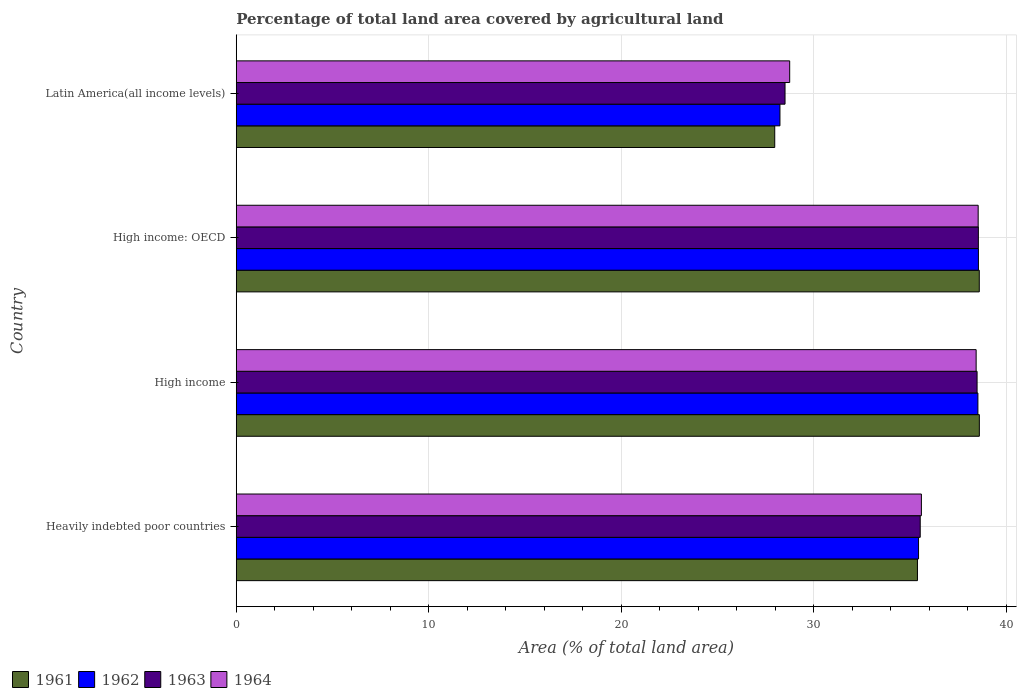How many different coloured bars are there?
Give a very brief answer. 4. Are the number of bars per tick equal to the number of legend labels?
Your answer should be very brief. Yes. Are the number of bars on each tick of the Y-axis equal?
Your answer should be compact. Yes. How many bars are there on the 2nd tick from the top?
Offer a terse response. 4. What is the label of the 2nd group of bars from the top?
Provide a succinct answer. High income: OECD. In how many cases, is the number of bars for a given country not equal to the number of legend labels?
Offer a terse response. 0. What is the percentage of agricultural land in 1962 in High income?
Keep it short and to the point. 38.52. Across all countries, what is the maximum percentage of agricultural land in 1964?
Offer a terse response. 38.53. Across all countries, what is the minimum percentage of agricultural land in 1964?
Your answer should be compact. 28.74. In which country was the percentage of agricultural land in 1961 minimum?
Make the answer very short. Latin America(all income levels). What is the total percentage of agricultural land in 1963 in the graph?
Keep it short and to the point. 141.05. What is the difference between the percentage of agricultural land in 1964 in Heavily indebted poor countries and that in Latin America(all income levels)?
Your answer should be very brief. 6.84. What is the difference between the percentage of agricultural land in 1963 in Heavily indebted poor countries and the percentage of agricultural land in 1961 in Latin America(all income levels)?
Make the answer very short. 7.56. What is the average percentage of agricultural land in 1961 per country?
Your answer should be compact. 35.13. What is the difference between the percentage of agricultural land in 1961 and percentage of agricultural land in 1964 in High income?
Your answer should be compact. 0.17. In how many countries, is the percentage of agricultural land in 1964 greater than 32 %?
Provide a short and direct response. 3. What is the ratio of the percentage of agricultural land in 1963 in High income: OECD to that in Latin America(all income levels)?
Your answer should be compact. 1.35. Is the difference between the percentage of agricultural land in 1961 in High income and Latin America(all income levels) greater than the difference between the percentage of agricultural land in 1964 in High income and Latin America(all income levels)?
Make the answer very short. Yes. What is the difference between the highest and the second highest percentage of agricultural land in 1963?
Ensure brevity in your answer.  0.07. What is the difference between the highest and the lowest percentage of agricultural land in 1962?
Ensure brevity in your answer.  10.31. Is it the case that in every country, the sum of the percentage of agricultural land in 1961 and percentage of agricultural land in 1964 is greater than the sum of percentage of agricultural land in 1963 and percentage of agricultural land in 1962?
Give a very brief answer. No. What does the 1st bar from the top in Heavily indebted poor countries represents?
Make the answer very short. 1964. Are the values on the major ticks of X-axis written in scientific E-notation?
Give a very brief answer. No. Does the graph contain grids?
Make the answer very short. Yes. How are the legend labels stacked?
Your answer should be compact. Horizontal. What is the title of the graph?
Your answer should be compact. Percentage of total land area covered by agricultural land. What is the label or title of the X-axis?
Ensure brevity in your answer.  Area (% of total land area). What is the Area (% of total land area) in 1961 in Heavily indebted poor countries?
Provide a short and direct response. 35.38. What is the Area (% of total land area) of 1962 in Heavily indebted poor countries?
Provide a succinct answer. 35.44. What is the Area (% of total land area) of 1963 in Heavily indebted poor countries?
Your response must be concise. 35.52. What is the Area (% of total land area) in 1964 in Heavily indebted poor countries?
Ensure brevity in your answer.  35.59. What is the Area (% of total land area) in 1961 in High income?
Give a very brief answer. 38.59. What is the Area (% of total land area) of 1962 in High income?
Offer a terse response. 38.52. What is the Area (% of total land area) of 1963 in High income?
Give a very brief answer. 38.48. What is the Area (% of total land area) of 1964 in High income?
Provide a short and direct response. 38.43. What is the Area (% of total land area) of 1961 in High income: OECD?
Provide a succinct answer. 38.59. What is the Area (% of total land area) in 1962 in High income: OECD?
Keep it short and to the point. 38.55. What is the Area (% of total land area) in 1963 in High income: OECD?
Your response must be concise. 38.54. What is the Area (% of total land area) in 1964 in High income: OECD?
Provide a succinct answer. 38.53. What is the Area (% of total land area) of 1961 in Latin America(all income levels)?
Your answer should be compact. 27.97. What is the Area (% of total land area) of 1962 in Latin America(all income levels)?
Offer a very short reply. 28.24. What is the Area (% of total land area) of 1963 in Latin America(all income levels)?
Provide a succinct answer. 28.5. What is the Area (% of total land area) in 1964 in Latin America(all income levels)?
Offer a terse response. 28.74. Across all countries, what is the maximum Area (% of total land area) of 1961?
Your answer should be compact. 38.59. Across all countries, what is the maximum Area (% of total land area) in 1962?
Your answer should be compact. 38.55. Across all countries, what is the maximum Area (% of total land area) of 1963?
Provide a short and direct response. 38.54. Across all countries, what is the maximum Area (% of total land area) of 1964?
Your answer should be very brief. 38.53. Across all countries, what is the minimum Area (% of total land area) of 1961?
Give a very brief answer. 27.97. Across all countries, what is the minimum Area (% of total land area) of 1962?
Make the answer very short. 28.24. Across all countries, what is the minimum Area (% of total land area) of 1963?
Offer a terse response. 28.5. Across all countries, what is the minimum Area (% of total land area) of 1964?
Ensure brevity in your answer.  28.74. What is the total Area (% of total land area) in 1961 in the graph?
Provide a short and direct response. 140.54. What is the total Area (% of total land area) in 1962 in the graph?
Provide a short and direct response. 140.75. What is the total Area (% of total land area) of 1963 in the graph?
Provide a short and direct response. 141.05. What is the total Area (% of total land area) in 1964 in the graph?
Provide a succinct answer. 141.29. What is the difference between the Area (% of total land area) in 1961 in Heavily indebted poor countries and that in High income?
Offer a very short reply. -3.21. What is the difference between the Area (% of total land area) in 1962 in Heavily indebted poor countries and that in High income?
Provide a short and direct response. -3.08. What is the difference between the Area (% of total land area) in 1963 in Heavily indebted poor countries and that in High income?
Ensure brevity in your answer.  -2.95. What is the difference between the Area (% of total land area) of 1964 in Heavily indebted poor countries and that in High income?
Your response must be concise. -2.84. What is the difference between the Area (% of total land area) of 1961 in Heavily indebted poor countries and that in High income: OECD?
Your answer should be compact. -3.21. What is the difference between the Area (% of total land area) in 1962 in Heavily indebted poor countries and that in High income: OECD?
Your answer should be very brief. -3.11. What is the difference between the Area (% of total land area) in 1963 in Heavily indebted poor countries and that in High income: OECD?
Ensure brevity in your answer.  -3.02. What is the difference between the Area (% of total land area) in 1964 in Heavily indebted poor countries and that in High income: OECD?
Give a very brief answer. -2.95. What is the difference between the Area (% of total land area) in 1961 in Heavily indebted poor countries and that in Latin America(all income levels)?
Your answer should be very brief. 7.41. What is the difference between the Area (% of total land area) of 1962 in Heavily indebted poor countries and that in Latin America(all income levels)?
Offer a terse response. 7.2. What is the difference between the Area (% of total land area) in 1963 in Heavily indebted poor countries and that in Latin America(all income levels)?
Your response must be concise. 7.02. What is the difference between the Area (% of total land area) of 1964 in Heavily indebted poor countries and that in Latin America(all income levels)?
Your answer should be compact. 6.84. What is the difference between the Area (% of total land area) in 1961 in High income and that in High income: OECD?
Offer a very short reply. 0. What is the difference between the Area (% of total land area) of 1962 in High income and that in High income: OECD?
Your response must be concise. -0.03. What is the difference between the Area (% of total land area) of 1963 in High income and that in High income: OECD?
Provide a short and direct response. -0.07. What is the difference between the Area (% of total land area) of 1964 in High income and that in High income: OECD?
Your answer should be very brief. -0.11. What is the difference between the Area (% of total land area) of 1961 in High income and that in Latin America(all income levels)?
Your response must be concise. 10.63. What is the difference between the Area (% of total land area) of 1962 in High income and that in Latin America(all income levels)?
Provide a short and direct response. 10.28. What is the difference between the Area (% of total land area) in 1963 in High income and that in Latin America(all income levels)?
Offer a terse response. 9.97. What is the difference between the Area (% of total land area) in 1964 in High income and that in Latin America(all income levels)?
Your answer should be compact. 9.68. What is the difference between the Area (% of total land area) of 1961 in High income: OECD and that in Latin America(all income levels)?
Provide a short and direct response. 10.62. What is the difference between the Area (% of total land area) of 1962 in High income: OECD and that in Latin America(all income levels)?
Provide a short and direct response. 10.31. What is the difference between the Area (% of total land area) of 1963 in High income: OECD and that in Latin America(all income levels)?
Keep it short and to the point. 10.04. What is the difference between the Area (% of total land area) of 1964 in High income: OECD and that in Latin America(all income levels)?
Your response must be concise. 9.79. What is the difference between the Area (% of total land area) in 1961 in Heavily indebted poor countries and the Area (% of total land area) in 1962 in High income?
Keep it short and to the point. -3.14. What is the difference between the Area (% of total land area) in 1961 in Heavily indebted poor countries and the Area (% of total land area) in 1963 in High income?
Provide a short and direct response. -3.1. What is the difference between the Area (% of total land area) in 1961 in Heavily indebted poor countries and the Area (% of total land area) in 1964 in High income?
Make the answer very short. -3.05. What is the difference between the Area (% of total land area) in 1962 in Heavily indebted poor countries and the Area (% of total land area) in 1963 in High income?
Ensure brevity in your answer.  -3.04. What is the difference between the Area (% of total land area) of 1962 in Heavily indebted poor countries and the Area (% of total land area) of 1964 in High income?
Ensure brevity in your answer.  -2.99. What is the difference between the Area (% of total land area) in 1963 in Heavily indebted poor countries and the Area (% of total land area) in 1964 in High income?
Give a very brief answer. -2.9. What is the difference between the Area (% of total land area) in 1961 in Heavily indebted poor countries and the Area (% of total land area) in 1962 in High income: OECD?
Provide a short and direct response. -3.17. What is the difference between the Area (% of total land area) of 1961 in Heavily indebted poor countries and the Area (% of total land area) of 1963 in High income: OECD?
Make the answer very short. -3.16. What is the difference between the Area (% of total land area) of 1961 in Heavily indebted poor countries and the Area (% of total land area) of 1964 in High income: OECD?
Make the answer very short. -3.15. What is the difference between the Area (% of total land area) in 1962 in Heavily indebted poor countries and the Area (% of total land area) in 1963 in High income: OECD?
Your answer should be very brief. -3.11. What is the difference between the Area (% of total land area) in 1962 in Heavily indebted poor countries and the Area (% of total land area) in 1964 in High income: OECD?
Offer a very short reply. -3.1. What is the difference between the Area (% of total land area) of 1963 in Heavily indebted poor countries and the Area (% of total land area) of 1964 in High income: OECD?
Provide a succinct answer. -3.01. What is the difference between the Area (% of total land area) of 1961 in Heavily indebted poor countries and the Area (% of total land area) of 1962 in Latin America(all income levels)?
Offer a terse response. 7.14. What is the difference between the Area (% of total land area) of 1961 in Heavily indebted poor countries and the Area (% of total land area) of 1963 in Latin America(all income levels)?
Your response must be concise. 6.88. What is the difference between the Area (% of total land area) in 1961 in Heavily indebted poor countries and the Area (% of total land area) in 1964 in Latin America(all income levels)?
Provide a short and direct response. 6.64. What is the difference between the Area (% of total land area) of 1962 in Heavily indebted poor countries and the Area (% of total land area) of 1963 in Latin America(all income levels)?
Offer a terse response. 6.93. What is the difference between the Area (% of total land area) in 1962 in Heavily indebted poor countries and the Area (% of total land area) in 1964 in Latin America(all income levels)?
Make the answer very short. 6.69. What is the difference between the Area (% of total land area) in 1963 in Heavily indebted poor countries and the Area (% of total land area) in 1964 in Latin America(all income levels)?
Offer a very short reply. 6.78. What is the difference between the Area (% of total land area) of 1961 in High income and the Area (% of total land area) of 1962 in High income: OECD?
Ensure brevity in your answer.  0.05. What is the difference between the Area (% of total land area) in 1961 in High income and the Area (% of total land area) in 1963 in High income: OECD?
Provide a succinct answer. 0.05. What is the difference between the Area (% of total land area) of 1961 in High income and the Area (% of total land area) of 1964 in High income: OECD?
Keep it short and to the point. 0.06. What is the difference between the Area (% of total land area) of 1962 in High income and the Area (% of total land area) of 1963 in High income: OECD?
Your response must be concise. -0.02. What is the difference between the Area (% of total land area) in 1962 in High income and the Area (% of total land area) in 1964 in High income: OECD?
Provide a succinct answer. -0.01. What is the difference between the Area (% of total land area) of 1963 in High income and the Area (% of total land area) of 1964 in High income: OECD?
Provide a short and direct response. -0.06. What is the difference between the Area (% of total land area) in 1961 in High income and the Area (% of total land area) in 1962 in Latin America(all income levels)?
Keep it short and to the point. 10.36. What is the difference between the Area (% of total land area) of 1961 in High income and the Area (% of total land area) of 1963 in Latin America(all income levels)?
Provide a succinct answer. 10.09. What is the difference between the Area (% of total land area) of 1961 in High income and the Area (% of total land area) of 1964 in Latin America(all income levels)?
Give a very brief answer. 9.85. What is the difference between the Area (% of total land area) of 1962 in High income and the Area (% of total land area) of 1963 in Latin America(all income levels)?
Offer a terse response. 10.02. What is the difference between the Area (% of total land area) in 1962 in High income and the Area (% of total land area) in 1964 in Latin America(all income levels)?
Offer a terse response. 9.78. What is the difference between the Area (% of total land area) of 1963 in High income and the Area (% of total land area) of 1964 in Latin America(all income levels)?
Give a very brief answer. 9.73. What is the difference between the Area (% of total land area) of 1961 in High income: OECD and the Area (% of total land area) of 1962 in Latin America(all income levels)?
Your answer should be very brief. 10.35. What is the difference between the Area (% of total land area) of 1961 in High income: OECD and the Area (% of total land area) of 1963 in Latin America(all income levels)?
Provide a succinct answer. 10.09. What is the difference between the Area (% of total land area) in 1961 in High income: OECD and the Area (% of total land area) in 1964 in Latin America(all income levels)?
Provide a short and direct response. 9.85. What is the difference between the Area (% of total land area) in 1962 in High income: OECD and the Area (% of total land area) in 1963 in Latin America(all income levels)?
Your answer should be compact. 10.04. What is the difference between the Area (% of total land area) of 1962 in High income: OECD and the Area (% of total land area) of 1964 in Latin America(all income levels)?
Provide a short and direct response. 9.8. What is the difference between the Area (% of total land area) in 1963 in High income: OECD and the Area (% of total land area) in 1964 in Latin America(all income levels)?
Give a very brief answer. 9.8. What is the average Area (% of total land area) in 1961 per country?
Keep it short and to the point. 35.13. What is the average Area (% of total land area) of 1962 per country?
Offer a terse response. 35.19. What is the average Area (% of total land area) of 1963 per country?
Ensure brevity in your answer.  35.26. What is the average Area (% of total land area) of 1964 per country?
Provide a succinct answer. 35.32. What is the difference between the Area (% of total land area) of 1961 and Area (% of total land area) of 1962 in Heavily indebted poor countries?
Give a very brief answer. -0.06. What is the difference between the Area (% of total land area) in 1961 and Area (% of total land area) in 1963 in Heavily indebted poor countries?
Keep it short and to the point. -0.14. What is the difference between the Area (% of total land area) in 1961 and Area (% of total land area) in 1964 in Heavily indebted poor countries?
Provide a succinct answer. -0.2. What is the difference between the Area (% of total land area) of 1962 and Area (% of total land area) of 1963 in Heavily indebted poor countries?
Provide a succinct answer. -0.09. What is the difference between the Area (% of total land area) of 1962 and Area (% of total land area) of 1964 in Heavily indebted poor countries?
Your answer should be compact. -0.15. What is the difference between the Area (% of total land area) of 1963 and Area (% of total land area) of 1964 in Heavily indebted poor countries?
Provide a succinct answer. -0.06. What is the difference between the Area (% of total land area) of 1961 and Area (% of total land area) of 1962 in High income?
Provide a succinct answer. 0.07. What is the difference between the Area (% of total land area) in 1961 and Area (% of total land area) in 1963 in High income?
Make the answer very short. 0.12. What is the difference between the Area (% of total land area) in 1961 and Area (% of total land area) in 1964 in High income?
Provide a short and direct response. 0.17. What is the difference between the Area (% of total land area) of 1962 and Area (% of total land area) of 1963 in High income?
Provide a short and direct response. 0.04. What is the difference between the Area (% of total land area) of 1962 and Area (% of total land area) of 1964 in High income?
Provide a succinct answer. 0.09. What is the difference between the Area (% of total land area) in 1963 and Area (% of total land area) in 1964 in High income?
Make the answer very short. 0.05. What is the difference between the Area (% of total land area) of 1961 and Area (% of total land area) of 1962 in High income: OECD?
Your answer should be compact. 0.04. What is the difference between the Area (% of total land area) in 1961 and Area (% of total land area) in 1963 in High income: OECD?
Provide a succinct answer. 0.05. What is the difference between the Area (% of total land area) of 1961 and Area (% of total land area) of 1964 in High income: OECD?
Keep it short and to the point. 0.06. What is the difference between the Area (% of total land area) in 1962 and Area (% of total land area) in 1963 in High income: OECD?
Offer a terse response. 0. What is the difference between the Area (% of total land area) of 1962 and Area (% of total land area) of 1964 in High income: OECD?
Your answer should be very brief. 0.01. What is the difference between the Area (% of total land area) of 1963 and Area (% of total land area) of 1964 in High income: OECD?
Your answer should be compact. 0.01. What is the difference between the Area (% of total land area) in 1961 and Area (% of total land area) in 1962 in Latin America(all income levels)?
Make the answer very short. -0.27. What is the difference between the Area (% of total land area) of 1961 and Area (% of total land area) of 1963 in Latin America(all income levels)?
Make the answer very short. -0.54. What is the difference between the Area (% of total land area) of 1961 and Area (% of total land area) of 1964 in Latin America(all income levels)?
Your response must be concise. -0.78. What is the difference between the Area (% of total land area) of 1962 and Area (% of total land area) of 1963 in Latin America(all income levels)?
Keep it short and to the point. -0.26. What is the difference between the Area (% of total land area) in 1962 and Area (% of total land area) in 1964 in Latin America(all income levels)?
Your response must be concise. -0.51. What is the difference between the Area (% of total land area) in 1963 and Area (% of total land area) in 1964 in Latin America(all income levels)?
Your answer should be very brief. -0.24. What is the ratio of the Area (% of total land area) in 1961 in Heavily indebted poor countries to that in High income?
Your response must be concise. 0.92. What is the ratio of the Area (% of total land area) in 1963 in Heavily indebted poor countries to that in High income?
Provide a short and direct response. 0.92. What is the ratio of the Area (% of total land area) in 1964 in Heavily indebted poor countries to that in High income?
Provide a succinct answer. 0.93. What is the ratio of the Area (% of total land area) of 1961 in Heavily indebted poor countries to that in High income: OECD?
Offer a very short reply. 0.92. What is the ratio of the Area (% of total land area) in 1962 in Heavily indebted poor countries to that in High income: OECD?
Ensure brevity in your answer.  0.92. What is the ratio of the Area (% of total land area) of 1963 in Heavily indebted poor countries to that in High income: OECD?
Offer a terse response. 0.92. What is the ratio of the Area (% of total land area) in 1964 in Heavily indebted poor countries to that in High income: OECD?
Provide a succinct answer. 0.92. What is the ratio of the Area (% of total land area) of 1961 in Heavily indebted poor countries to that in Latin America(all income levels)?
Your response must be concise. 1.26. What is the ratio of the Area (% of total land area) of 1962 in Heavily indebted poor countries to that in Latin America(all income levels)?
Offer a terse response. 1.25. What is the ratio of the Area (% of total land area) in 1963 in Heavily indebted poor countries to that in Latin America(all income levels)?
Provide a succinct answer. 1.25. What is the ratio of the Area (% of total land area) of 1964 in Heavily indebted poor countries to that in Latin America(all income levels)?
Ensure brevity in your answer.  1.24. What is the ratio of the Area (% of total land area) of 1961 in High income to that in High income: OECD?
Give a very brief answer. 1. What is the ratio of the Area (% of total land area) in 1962 in High income to that in High income: OECD?
Ensure brevity in your answer.  1. What is the ratio of the Area (% of total land area) in 1961 in High income to that in Latin America(all income levels)?
Keep it short and to the point. 1.38. What is the ratio of the Area (% of total land area) of 1962 in High income to that in Latin America(all income levels)?
Offer a very short reply. 1.36. What is the ratio of the Area (% of total land area) in 1963 in High income to that in Latin America(all income levels)?
Your answer should be very brief. 1.35. What is the ratio of the Area (% of total land area) in 1964 in High income to that in Latin America(all income levels)?
Your answer should be very brief. 1.34. What is the ratio of the Area (% of total land area) of 1961 in High income: OECD to that in Latin America(all income levels)?
Provide a short and direct response. 1.38. What is the ratio of the Area (% of total land area) of 1962 in High income: OECD to that in Latin America(all income levels)?
Offer a terse response. 1.36. What is the ratio of the Area (% of total land area) of 1963 in High income: OECD to that in Latin America(all income levels)?
Your answer should be very brief. 1.35. What is the ratio of the Area (% of total land area) of 1964 in High income: OECD to that in Latin America(all income levels)?
Keep it short and to the point. 1.34. What is the difference between the highest and the second highest Area (% of total land area) in 1961?
Your answer should be very brief. 0. What is the difference between the highest and the second highest Area (% of total land area) in 1962?
Your answer should be very brief. 0.03. What is the difference between the highest and the second highest Area (% of total land area) of 1963?
Offer a very short reply. 0.07. What is the difference between the highest and the second highest Area (% of total land area) in 1964?
Offer a terse response. 0.11. What is the difference between the highest and the lowest Area (% of total land area) of 1961?
Your answer should be compact. 10.63. What is the difference between the highest and the lowest Area (% of total land area) of 1962?
Your answer should be very brief. 10.31. What is the difference between the highest and the lowest Area (% of total land area) in 1963?
Offer a very short reply. 10.04. What is the difference between the highest and the lowest Area (% of total land area) of 1964?
Provide a succinct answer. 9.79. 